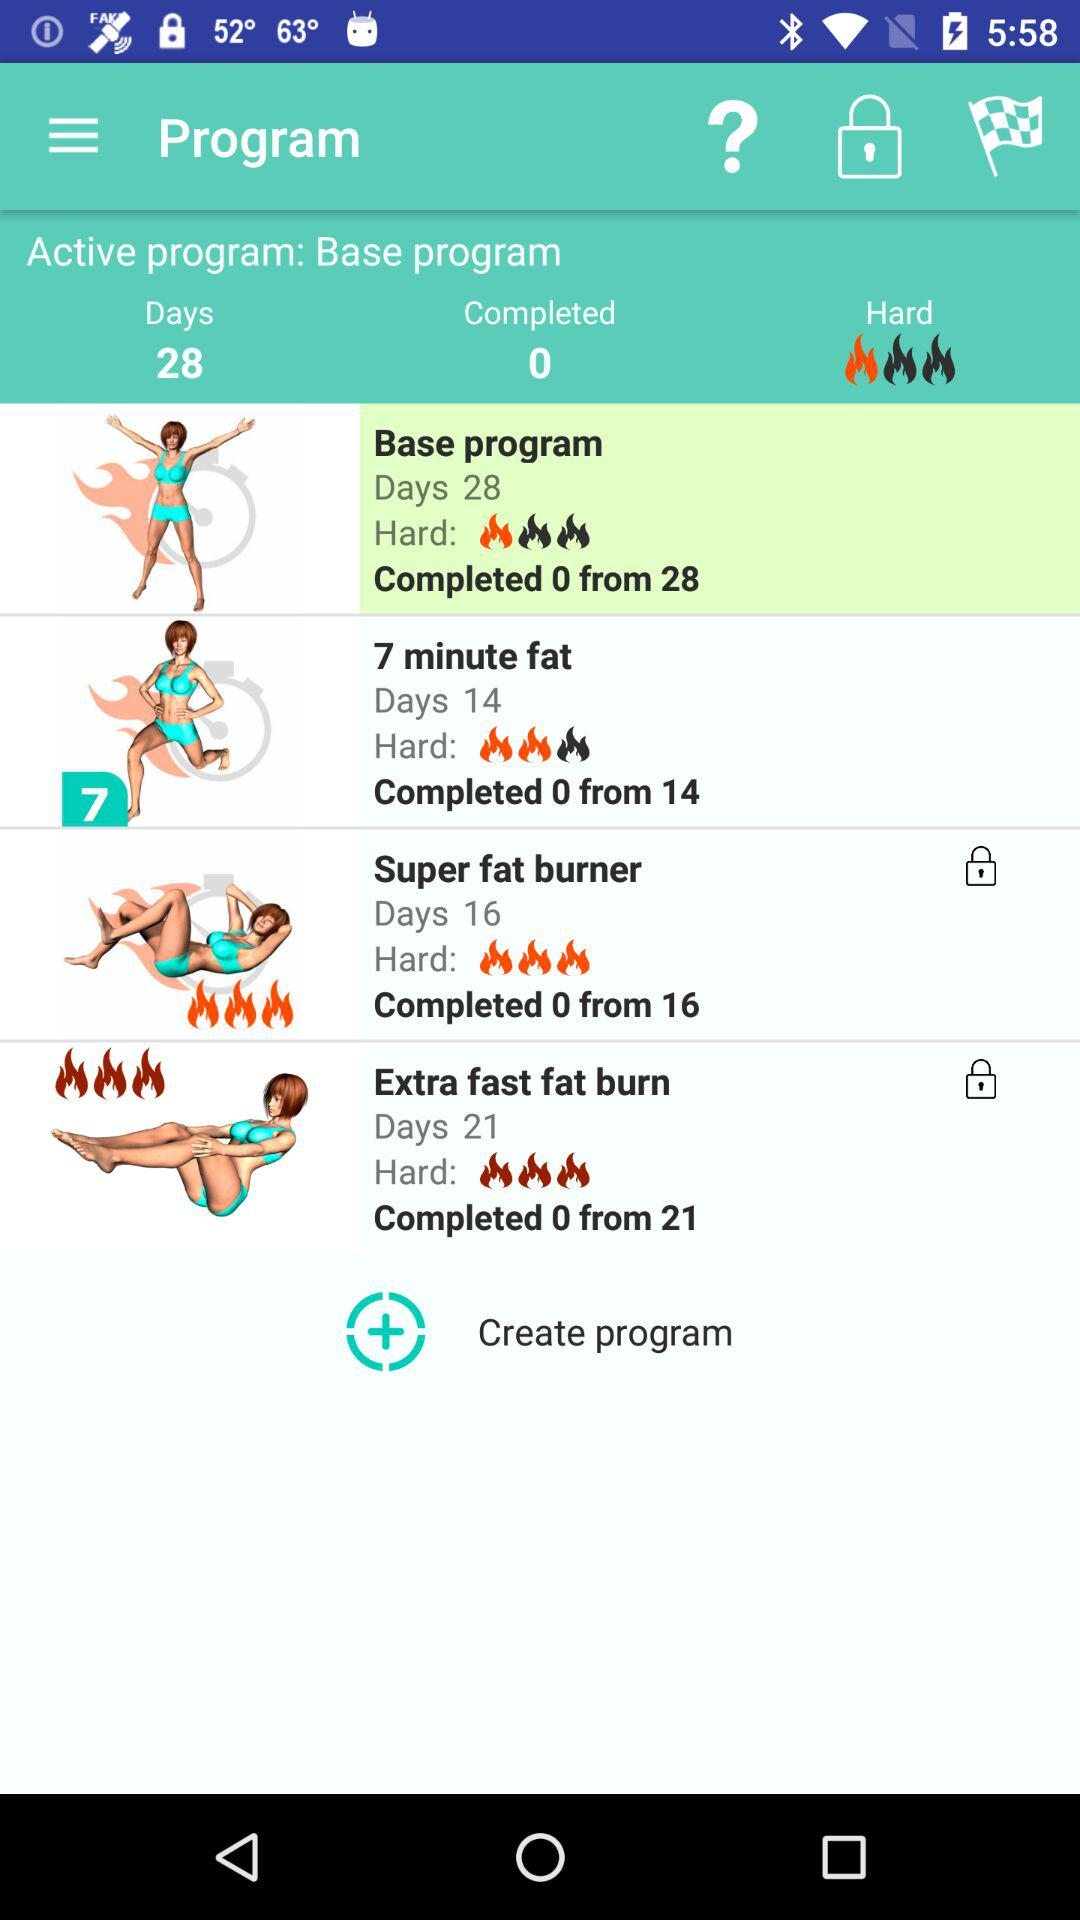How many programs are there?
Answer the question using a single word or phrase. 4 